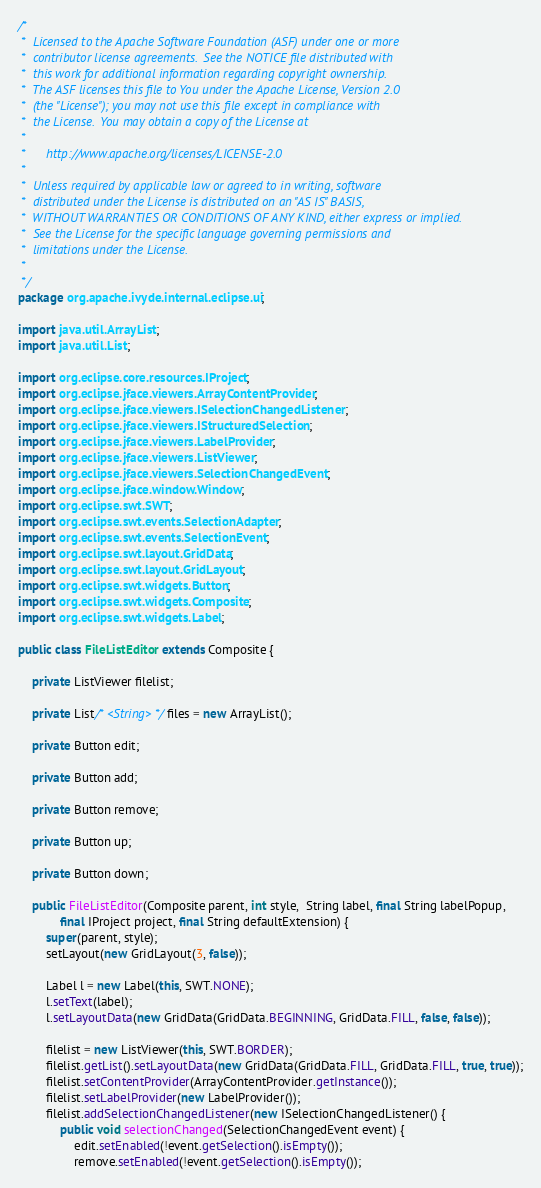Convert code to text. <code><loc_0><loc_0><loc_500><loc_500><_Java_>/*
 *  Licensed to the Apache Software Foundation (ASF) under one or more
 *  contributor license agreements.  See the NOTICE file distributed with
 *  this work for additional information regarding copyright ownership.
 *  The ASF licenses this file to You under the Apache License, Version 2.0
 *  (the "License"); you may not use this file except in compliance with
 *  the License.  You may obtain a copy of the License at
 *
 *      http://www.apache.org/licenses/LICENSE-2.0
 *
 *  Unless required by applicable law or agreed to in writing, software
 *  distributed under the License is distributed on an "AS IS" BASIS,
 *  WITHOUT WARRANTIES OR CONDITIONS OF ANY KIND, either express or implied.
 *  See the License for the specific language governing permissions and
 *  limitations under the License.
 *
 */
package org.apache.ivyde.internal.eclipse.ui;

import java.util.ArrayList;
import java.util.List;

import org.eclipse.core.resources.IProject;
import org.eclipse.jface.viewers.ArrayContentProvider;
import org.eclipse.jface.viewers.ISelectionChangedListener;
import org.eclipse.jface.viewers.IStructuredSelection;
import org.eclipse.jface.viewers.LabelProvider;
import org.eclipse.jface.viewers.ListViewer;
import org.eclipse.jface.viewers.SelectionChangedEvent;
import org.eclipse.jface.window.Window;
import org.eclipse.swt.SWT;
import org.eclipse.swt.events.SelectionAdapter;
import org.eclipse.swt.events.SelectionEvent;
import org.eclipse.swt.layout.GridData;
import org.eclipse.swt.layout.GridLayout;
import org.eclipse.swt.widgets.Button;
import org.eclipse.swt.widgets.Composite;
import org.eclipse.swt.widgets.Label;

public class FileListEditor extends Composite {

    private ListViewer filelist;

    private List/* <String> */files = new ArrayList();

    private Button edit;

    private Button add;

    private Button remove;

    private Button up;

    private Button down;

    public FileListEditor(Composite parent, int style,  String label, final String labelPopup,
            final IProject project, final String defaultExtension) {
        super(parent, style);
        setLayout(new GridLayout(3, false));

        Label l = new Label(this, SWT.NONE);
        l.setText(label);
        l.setLayoutData(new GridData(GridData.BEGINNING, GridData.FILL, false, false));

        filelist = new ListViewer(this, SWT.BORDER);
        filelist.getList().setLayoutData(new GridData(GridData.FILL, GridData.FILL, true, true));
        filelist.setContentProvider(ArrayContentProvider.getInstance());
        filelist.setLabelProvider(new LabelProvider());
        filelist.addSelectionChangedListener(new ISelectionChangedListener() {
            public void selectionChanged(SelectionChangedEvent event) {
                edit.setEnabled(!event.getSelection().isEmpty());
                remove.setEnabled(!event.getSelection().isEmpty());</code> 